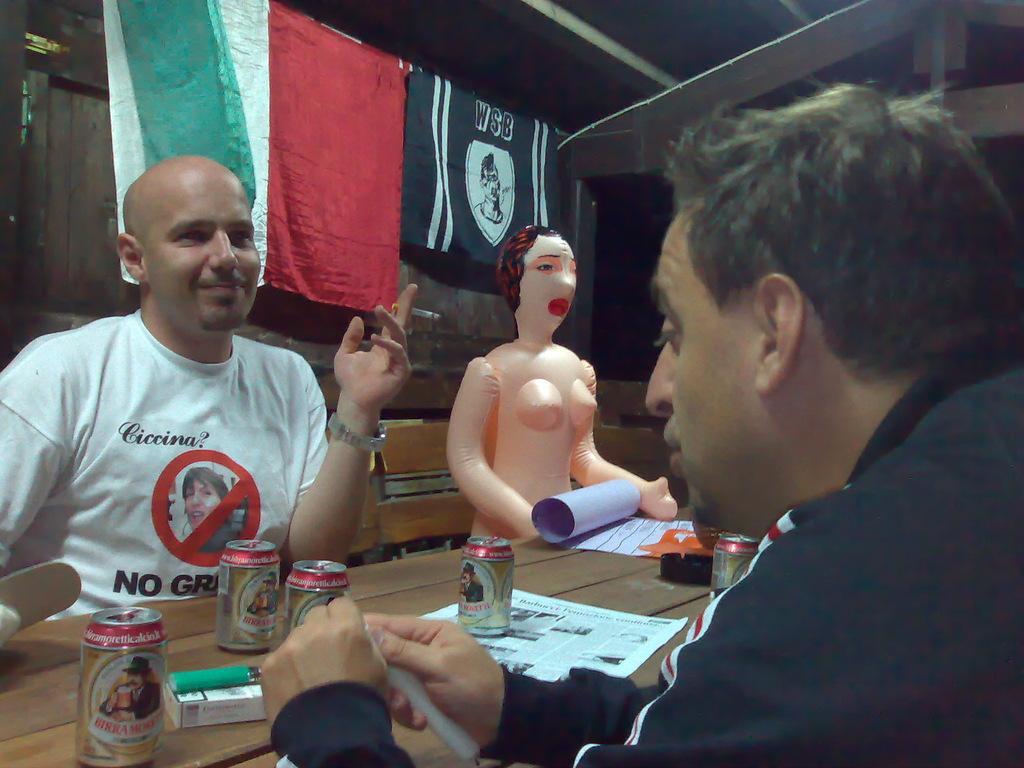Please provide a concise description of this image. In this image I can see two persons sitting. In front the person is wearing black color dress and the person at left is wearing white color shirt and I can see few tins, papers on the table and I can also see the mannequin. Background I can see few flags in black, red, white and green color. 